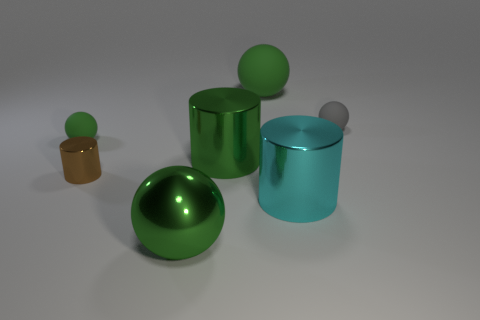There is a large matte object; is its color the same as the large sphere in front of the small gray ball?
Ensure brevity in your answer.  Yes. Does the tiny rubber sphere to the left of the small gray rubber sphere have the same color as the big matte thing?
Make the answer very short. Yes. There is a green sphere that is to the right of the tiny green rubber sphere and behind the cyan metallic object; what is its material?
Provide a short and direct response. Rubber. There is a small sphere that is left of the large cyan object; what material is it?
Keep it short and to the point. Rubber. What is the material of the small thing that is the same color as the big rubber ball?
Your answer should be very brief. Rubber. Is there a metal cylinder of the same color as the metal ball?
Make the answer very short. Yes. Are there fewer large green metal cylinders that are in front of the brown shiny object than tiny red cylinders?
Provide a short and direct response. No. There is a brown object in front of the large green matte ball; is there a green shiny object in front of it?
Your answer should be compact. Yes. Do the metallic ball and the cyan metallic thing have the same size?
Keep it short and to the point. Yes. What is the material of the tiny object that is right of the cyan cylinder on the right side of the tiny ball left of the big green matte ball?
Your answer should be compact. Rubber. 